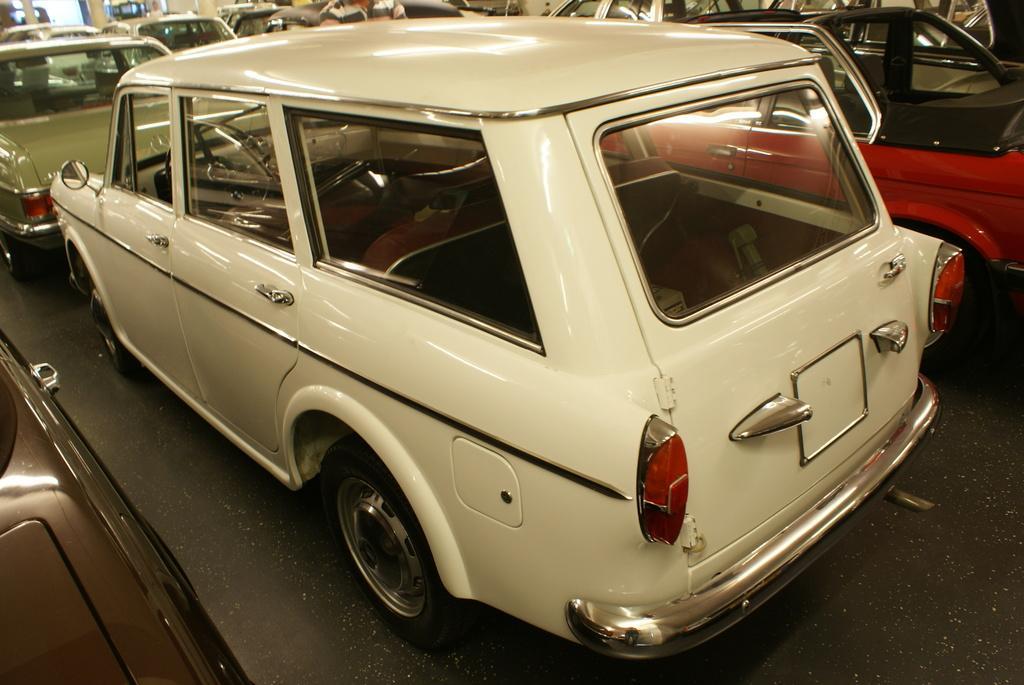Could you give a brief overview of what you see in this image? This image consist of many cars. In the front, there is a car in white color. To the left, there is a mirror. At the top there is a top of the car. In the back, there is a bumper in silver color. At the bottom, there are tyres on the floor. 